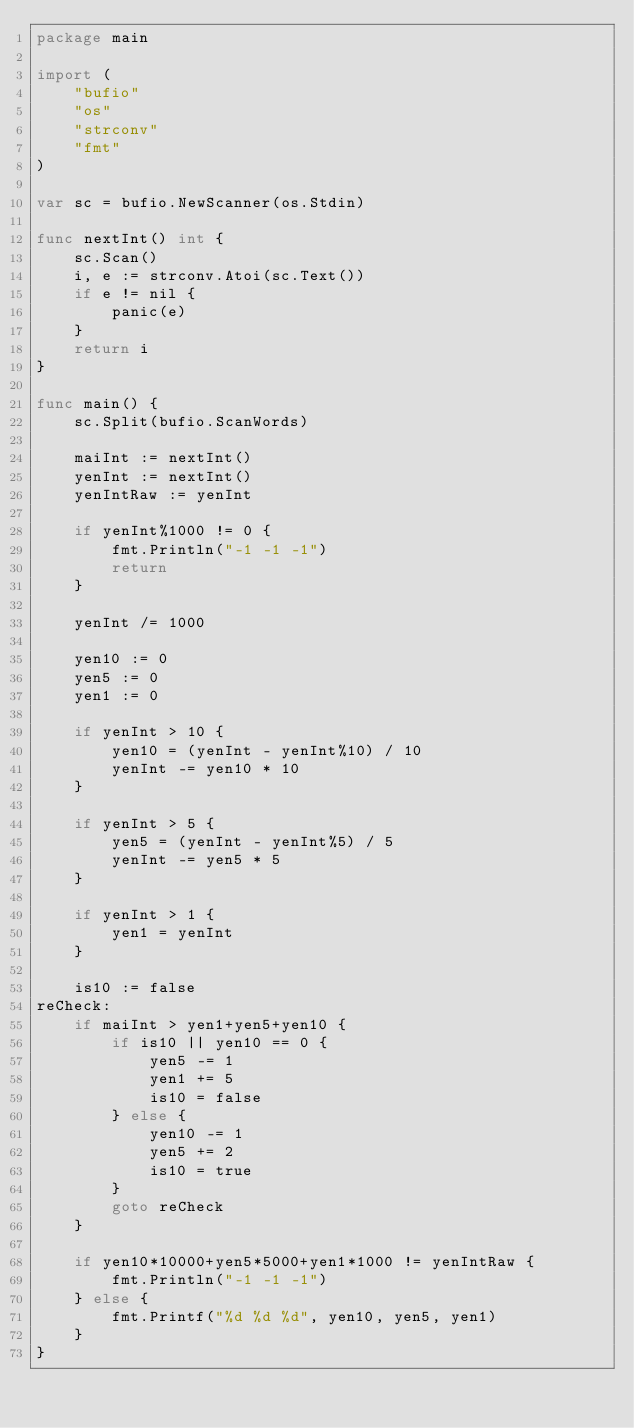Convert code to text. <code><loc_0><loc_0><loc_500><loc_500><_Go_>package main

import (
	"bufio"
	"os"
	"strconv"
	"fmt"
)

var sc = bufio.NewScanner(os.Stdin)

func nextInt() int {
	sc.Scan()
	i, e := strconv.Atoi(sc.Text())
	if e != nil {
		panic(e)
	}
	return i
}

func main() {
	sc.Split(bufio.ScanWords)

	maiInt := nextInt()
	yenInt := nextInt()
	yenIntRaw := yenInt

	if yenInt%1000 != 0 {
		fmt.Println("-1 -1 -1")
		return
	}

	yenInt /= 1000

	yen10 := 0
	yen5 := 0
	yen1 := 0

	if yenInt > 10 {
		yen10 = (yenInt - yenInt%10) / 10
		yenInt -= yen10 * 10
	}

	if yenInt > 5 {
		yen5 = (yenInt - yenInt%5) / 5
		yenInt -= yen5 * 5
	}

	if yenInt > 1 {
		yen1 = yenInt
	}

	is10 := false
reCheck:
	if maiInt > yen1+yen5+yen10 {
		if is10 || yen10 == 0 {
			yen5 -= 1
			yen1 += 5
			is10 = false
		} else {
			yen10 -= 1
			yen5 += 2
			is10 = true
		}
		goto reCheck
	}

	if yen10*10000+yen5*5000+yen1*1000 != yenIntRaw {
		fmt.Println("-1 -1 -1")
	} else {
		fmt.Printf("%d %d %d", yen10, yen5, yen1)
	}
}
</code> 